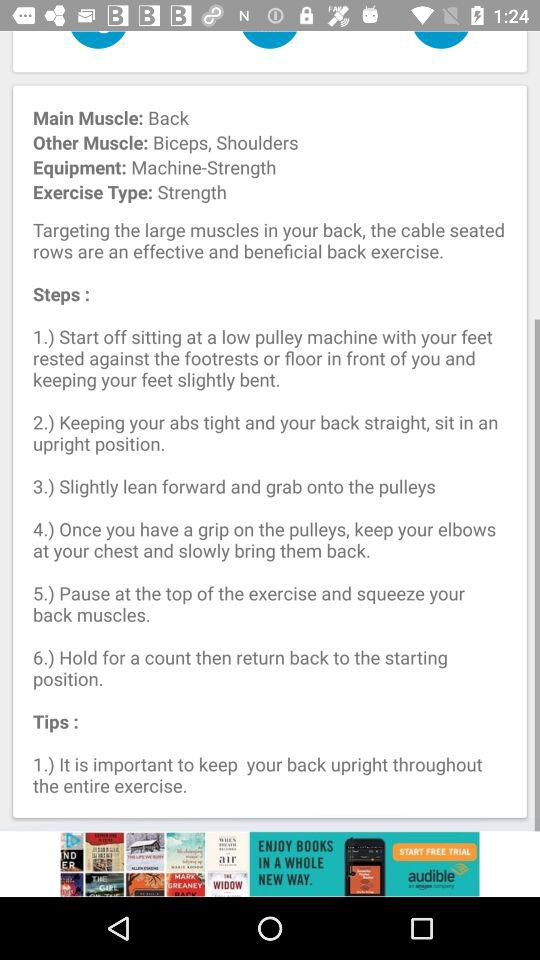How many other muscles does this exercise target?
Answer the question using a single word or phrase. 2 